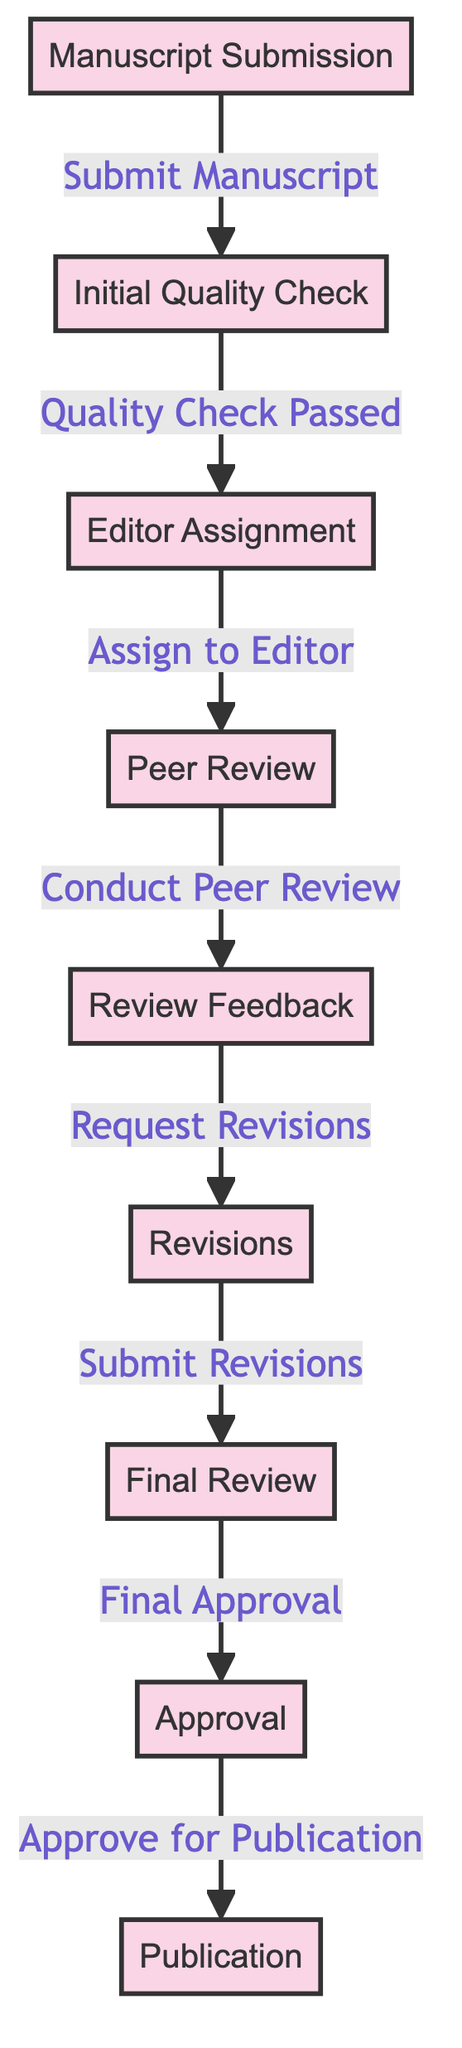What is the starting node of the manuscript review workflow? The starting node in this workflow is "Manuscript Submission," which indicates where the process begins.
Answer: Manuscript Submission How many nodes are present in the diagram? By counting each distinct point in the workflow, there are eight nodes: Manuscript Submission, Initial Quality Check, Editor Assignment, Peer Review, Review Feedback, Revisions, Final Review, and Approval.
Answer: 8 What is the label of the edge between "Initial Quality Check" and "Editor Assignment"? The edge between these two nodes is labeled "Quality Check Passed," indicating a successful transition from the quality check to the assignment of an editor.
Answer: Quality Check Passed What happens after "Review Feedback"? Following "Review Feedback," the next step in the workflow is "Revisions," where the author is requested to make changes based on the feedback provided.
Answer: Revisions Which node directly precedes "Approval"? The node that comes directly before "Approval" is "Final Review." This step requires the final assessment before approval can take place.
Answer: Final Review What is the last node in the manuscript review workflow? The last node in this workflow is "Publication," where the manuscript is finally published after obtaining all necessary approvals.
Answer: Publication If the initial quality check fails, what is the consequence according to the diagram? The diagram does not detail the consequences of a failed quality check; therefore, the process cannot proceed to the editor assignment. This means the manuscript would not continue through the workflow.
Answer: None (process halts) How many edges are there in the workflow? By counting the connections or edges leading from one node to another, there are seven edges in the graph that represent transitions between each step of the process.
Answer: 7 What action is taken during the peer review stage? During the "Peer Review," the specific action taken is "Conduct Peer Review," which involves evaluating the manuscript by assigned reviewers.
Answer: Conduct Peer Review 